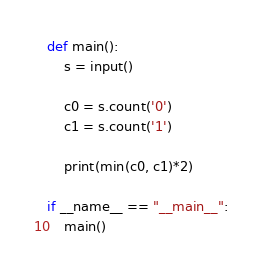Convert code to text. <code><loc_0><loc_0><loc_500><loc_500><_Python_>def main():
    s = input()

    c0 = s.count('0')
    c1 = s.count('1')

    print(min(c0, c1)*2)

if __name__ == "__main__":
    main()
</code> 